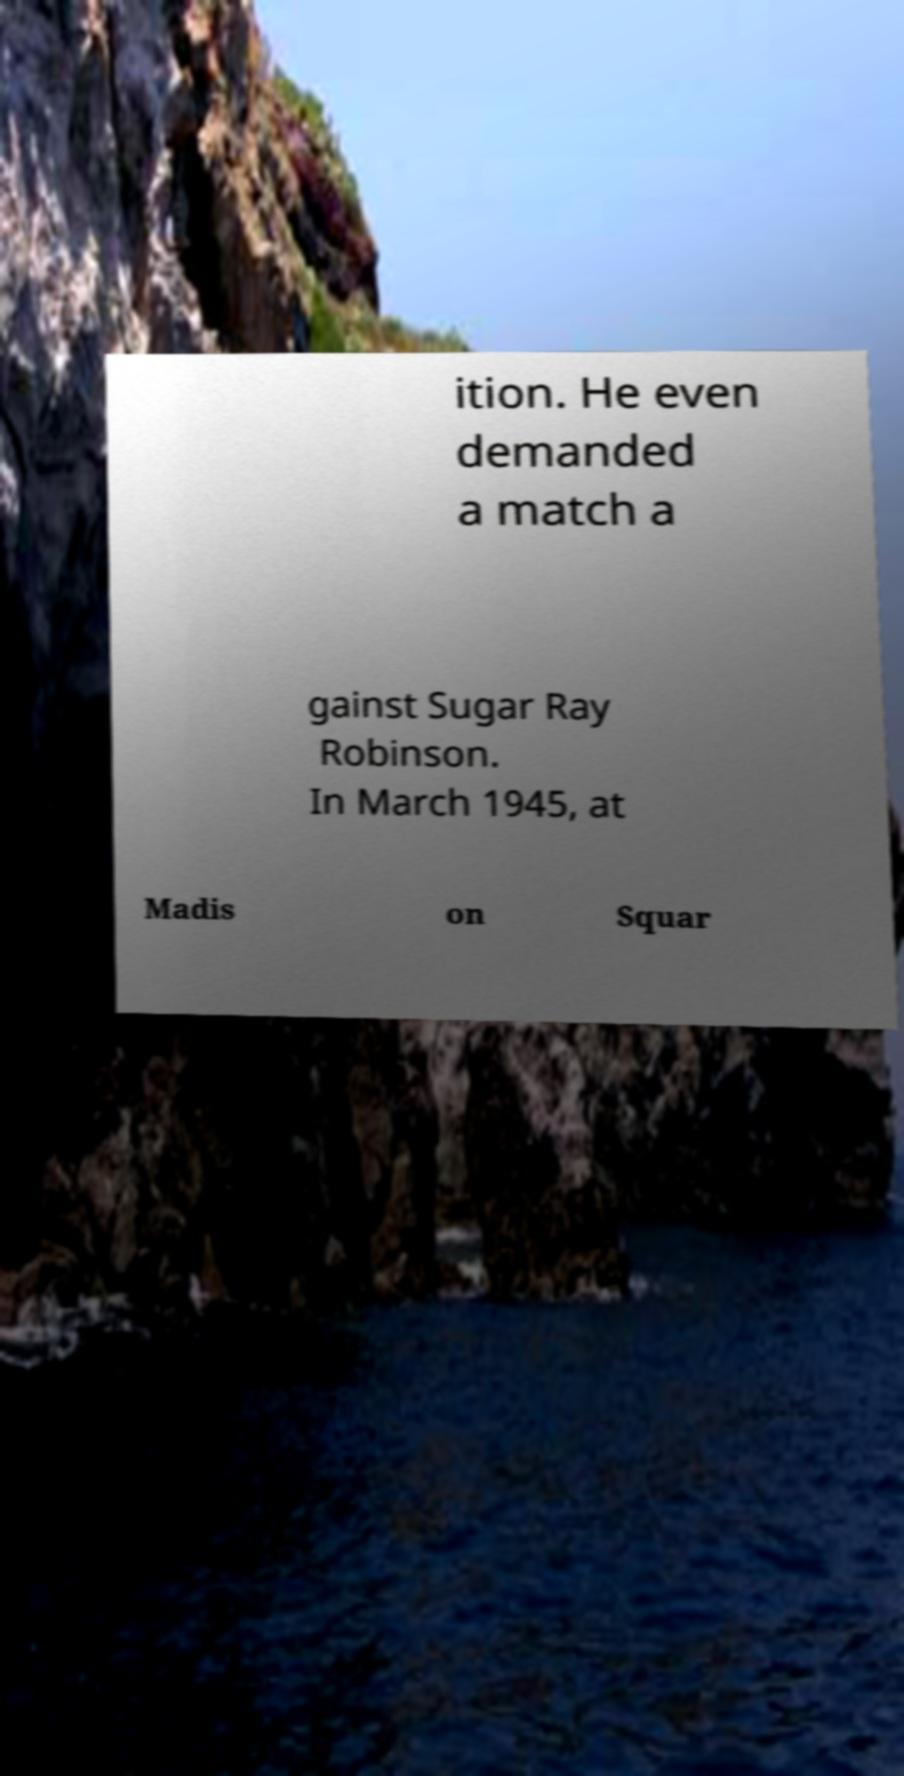For documentation purposes, I need the text within this image transcribed. Could you provide that? ition. He even demanded a match a gainst Sugar Ray Robinson. In March 1945, at Madis on Squar 